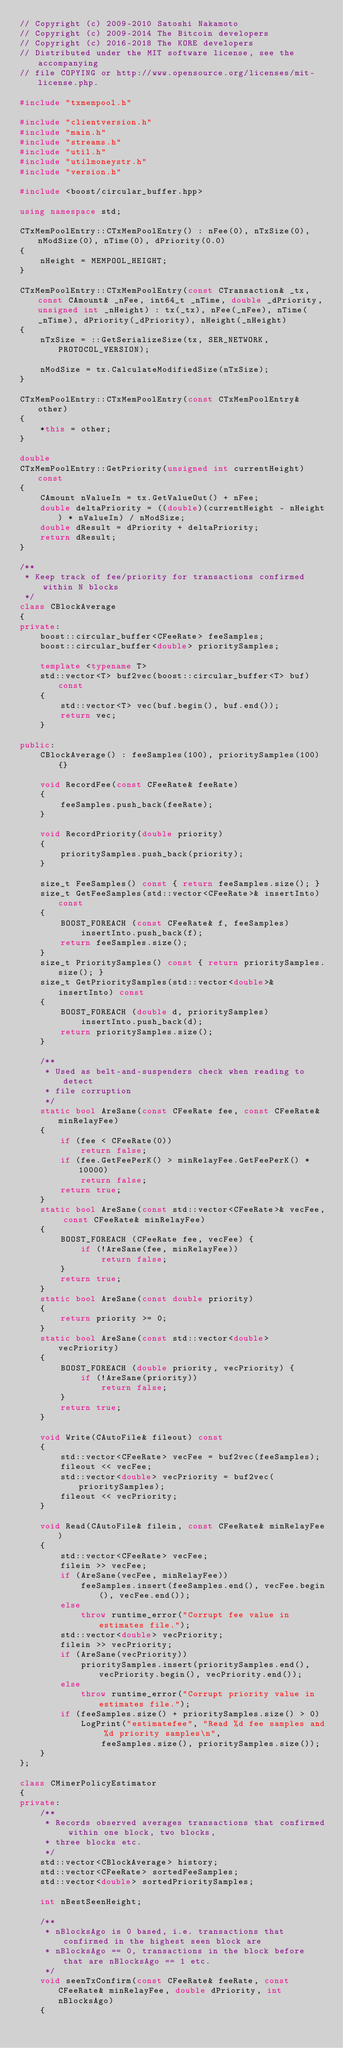Convert code to text. <code><loc_0><loc_0><loc_500><loc_500><_C++_>// Copyright (c) 2009-2010 Satoshi Nakamoto
// Copyright (c) 2009-2014 The Bitcoin developers
// Copyright (c) 2016-2018 The KORE developers
// Distributed under the MIT software license, see the accompanying
// file COPYING or http://www.opensource.org/licenses/mit-license.php.

#include "txmempool.h"

#include "clientversion.h"
#include "main.h"
#include "streams.h"
#include "util.h"
#include "utilmoneystr.h"
#include "version.h"

#include <boost/circular_buffer.hpp>

using namespace std;

CTxMemPoolEntry::CTxMemPoolEntry() : nFee(0), nTxSize(0), nModSize(0), nTime(0), dPriority(0.0)
{
    nHeight = MEMPOOL_HEIGHT;
}

CTxMemPoolEntry::CTxMemPoolEntry(const CTransaction& _tx, const CAmount& _nFee, int64_t _nTime, double _dPriority, unsigned int _nHeight) : tx(_tx), nFee(_nFee), nTime(_nTime), dPriority(_dPriority), nHeight(_nHeight)
{
    nTxSize = ::GetSerializeSize(tx, SER_NETWORK, PROTOCOL_VERSION);

    nModSize = tx.CalculateModifiedSize(nTxSize);
}

CTxMemPoolEntry::CTxMemPoolEntry(const CTxMemPoolEntry& other)
{
    *this = other;
}

double
CTxMemPoolEntry::GetPriority(unsigned int currentHeight) const
{
    CAmount nValueIn = tx.GetValueOut() + nFee;
    double deltaPriority = ((double)(currentHeight - nHeight) * nValueIn) / nModSize;
    double dResult = dPriority + deltaPriority;
    return dResult;
}

/**
 * Keep track of fee/priority for transactions confirmed within N blocks
 */
class CBlockAverage
{
private:
    boost::circular_buffer<CFeeRate> feeSamples;
    boost::circular_buffer<double> prioritySamples;

    template <typename T>
    std::vector<T> buf2vec(boost::circular_buffer<T> buf) const
    {
        std::vector<T> vec(buf.begin(), buf.end());
        return vec;
    }

public:
    CBlockAverage() : feeSamples(100), prioritySamples(100) {}

    void RecordFee(const CFeeRate& feeRate)
    {
        feeSamples.push_back(feeRate);
    }

    void RecordPriority(double priority)
    {
        prioritySamples.push_back(priority);
    }

    size_t FeeSamples() const { return feeSamples.size(); }
    size_t GetFeeSamples(std::vector<CFeeRate>& insertInto) const
    {
        BOOST_FOREACH (const CFeeRate& f, feeSamples)
            insertInto.push_back(f);
        return feeSamples.size();
    }
    size_t PrioritySamples() const { return prioritySamples.size(); }
    size_t GetPrioritySamples(std::vector<double>& insertInto) const
    {
        BOOST_FOREACH (double d, prioritySamples)
            insertInto.push_back(d);
        return prioritySamples.size();
    }

    /**
     * Used as belt-and-suspenders check when reading to detect
     * file corruption
     */
    static bool AreSane(const CFeeRate fee, const CFeeRate& minRelayFee)
    {
        if (fee < CFeeRate(0))
            return false;
        if (fee.GetFeePerK() > minRelayFee.GetFeePerK() * 10000)
            return false;
        return true;
    }
    static bool AreSane(const std::vector<CFeeRate>& vecFee, const CFeeRate& minRelayFee)
    {
        BOOST_FOREACH (CFeeRate fee, vecFee) {
            if (!AreSane(fee, minRelayFee))
                return false;
        }
        return true;
    }
    static bool AreSane(const double priority)
    {
        return priority >= 0;
    }
    static bool AreSane(const std::vector<double> vecPriority)
    {
        BOOST_FOREACH (double priority, vecPriority) {
            if (!AreSane(priority))
                return false;
        }
        return true;
    }

    void Write(CAutoFile& fileout) const
    {
        std::vector<CFeeRate> vecFee = buf2vec(feeSamples);
        fileout << vecFee;
        std::vector<double> vecPriority = buf2vec(prioritySamples);
        fileout << vecPriority;
    }

    void Read(CAutoFile& filein, const CFeeRate& minRelayFee)
    {
        std::vector<CFeeRate> vecFee;
        filein >> vecFee;
        if (AreSane(vecFee, minRelayFee))
            feeSamples.insert(feeSamples.end(), vecFee.begin(), vecFee.end());
        else
            throw runtime_error("Corrupt fee value in estimates file.");
        std::vector<double> vecPriority;
        filein >> vecPriority;
        if (AreSane(vecPriority))
            prioritySamples.insert(prioritySamples.end(), vecPriority.begin(), vecPriority.end());
        else
            throw runtime_error("Corrupt priority value in estimates file.");
        if (feeSamples.size() + prioritySamples.size() > 0)
            LogPrint("estimatefee", "Read %d fee samples and %d priority samples\n",
                feeSamples.size(), prioritySamples.size());
    }
};

class CMinerPolicyEstimator
{
private:
    /**
     * Records observed averages transactions that confirmed within one block, two blocks,
     * three blocks etc.
     */
    std::vector<CBlockAverage> history;
    std::vector<CFeeRate> sortedFeeSamples;
    std::vector<double> sortedPrioritySamples;

    int nBestSeenHeight;

    /**
     * nBlocksAgo is 0 based, i.e. transactions that confirmed in the highest seen block are
     * nBlocksAgo == 0, transactions in the block before that are nBlocksAgo == 1 etc.
     */
    void seenTxConfirm(const CFeeRate& feeRate, const CFeeRate& minRelayFee, double dPriority, int nBlocksAgo)
    {</code> 